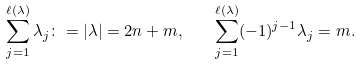Convert formula to latex. <formula><loc_0><loc_0><loc_500><loc_500>\sum _ { j = 1 } ^ { \ell ( \lambda ) } \lambda _ { j } \colon = | \lambda | = 2 n + m , \quad \sum _ { j = 1 } ^ { \ell ( \lambda ) } ( - 1 ) ^ { j - 1 } \lambda _ { j } = m .</formula> 